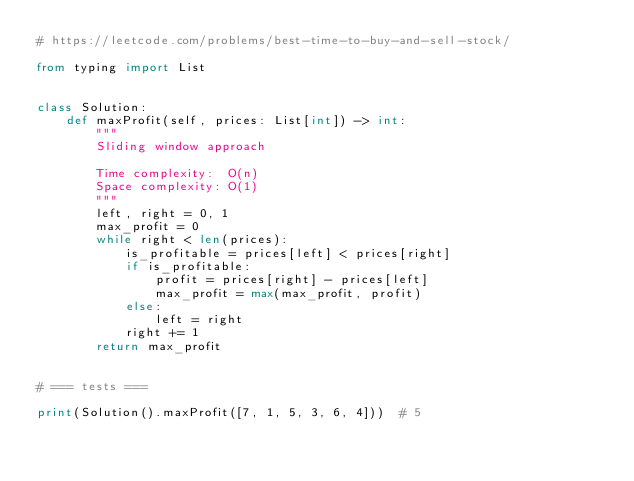<code> <loc_0><loc_0><loc_500><loc_500><_Python_># https://leetcode.com/problems/best-time-to-buy-and-sell-stock/

from typing import List


class Solution:
    def maxProfit(self, prices: List[int]) -> int:
        """
        Sliding window approach

        Time complexity:  O(n)
        Space complexity: O(1)
        """
        left, right = 0, 1
        max_profit = 0
        while right < len(prices):
            is_profitable = prices[left] < prices[right]
            if is_profitable:
                profit = prices[right] - prices[left]
                max_profit = max(max_profit, profit)
            else:
                left = right
            right += 1
        return max_profit


# === tests ===

print(Solution().maxProfit([7, 1, 5, 3, 6, 4]))  # 5
</code> 